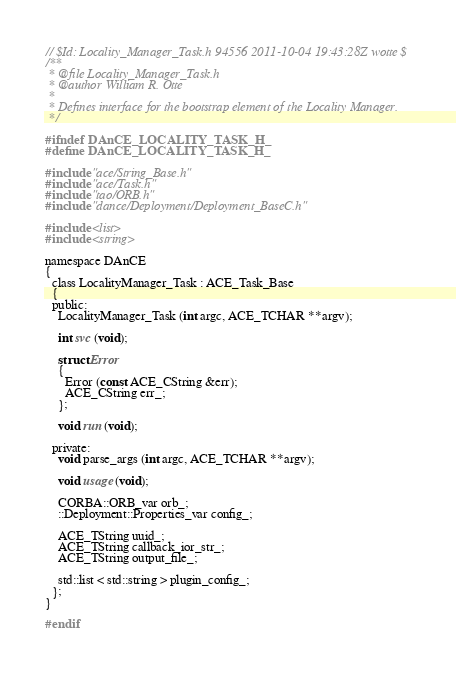Convert code to text. <code><loc_0><loc_0><loc_500><loc_500><_C_>// $Id: Locality_Manager_Task.h 94556 2011-10-04 19:43:28Z wotte $
/**
 * @file Locality_Manager_Task.h
 * @author William R. Otte
 *
 * Defines interface for the bootstrap element of the Locality Manager.
 */

#ifndef DAnCE_LOCALITY_TASK_H_
#define DAnCE_LOCALITY_TASK_H_

#include "ace/String_Base.h"
#include "ace/Task.h"
#include "tao/ORB.h"
#include "dance/Deployment/Deployment_BaseC.h"

#include <list>
#include <string>

namespace DAnCE
{
  class LocalityManager_Task : ACE_Task_Base
  {
  public:
    LocalityManager_Task (int argc, ACE_TCHAR **argv);

    int svc (void);

    struct Error
    {
      Error (const ACE_CString &err);
      ACE_CString err_;
    };

    void run (void);

  private:
    void parse_args (int argc, ACE_TCHAR **argv);

    void usage (void);

    CORBA::ORB_var orb_;
    ::Deployment::Properties_var config_;

    ACE_TString uuid_;
    ACE_TString callback_ior_str_;
    ACE_TString output_file_;

    std::list < std::string > plugin_config_;
  };
}

#endif
</code> 